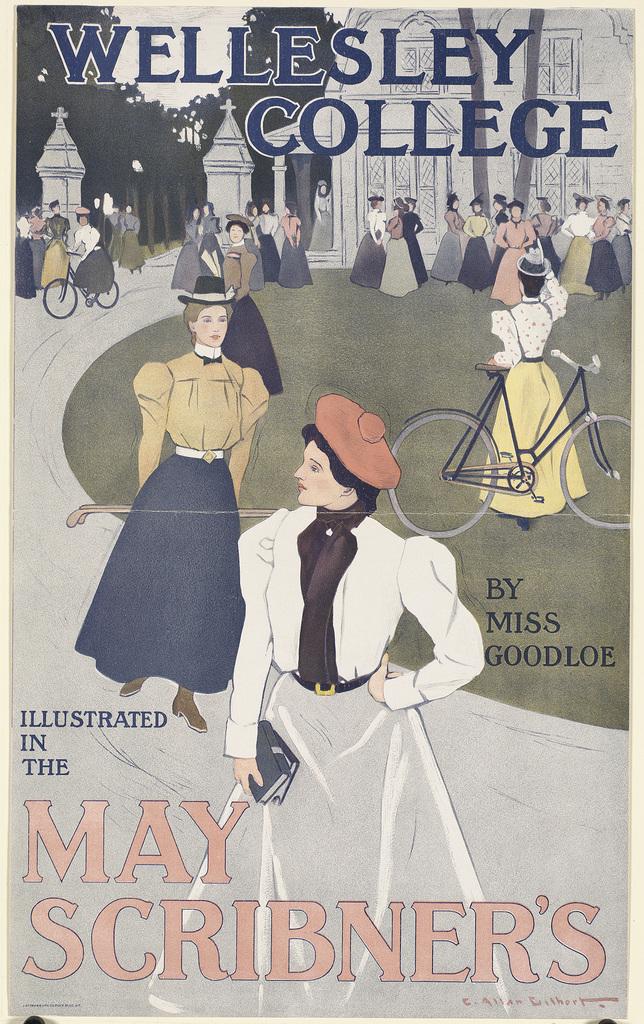Who illustrated the book?
Make the answer very short. May scribner's. What university is named on the top of the poster?
Provide a succinct answer. Wellesley college. 